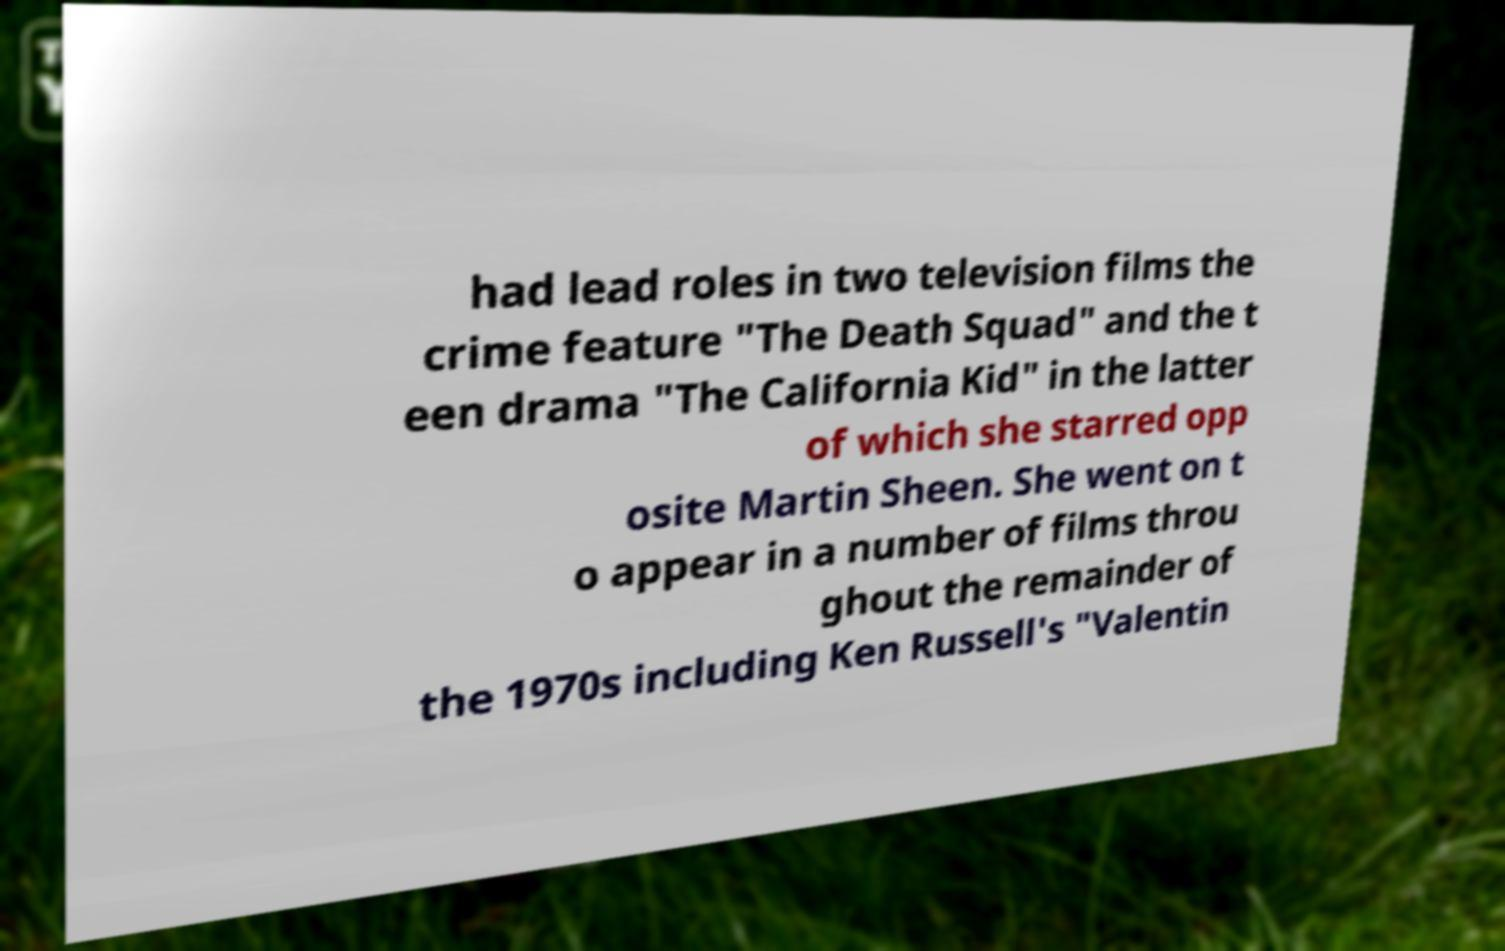For documentation purposes, I need the text within this image transcribed. Could you provide that? had lead roles in two television films the crime feature "The Death Squad" and the t een drama "The California Kid" in the latter of which she starred opp osite Martin Sheen. She went on t o appear in a number of films throu ghout the remainder of the 1970s including Ken Russell's "Valentin 